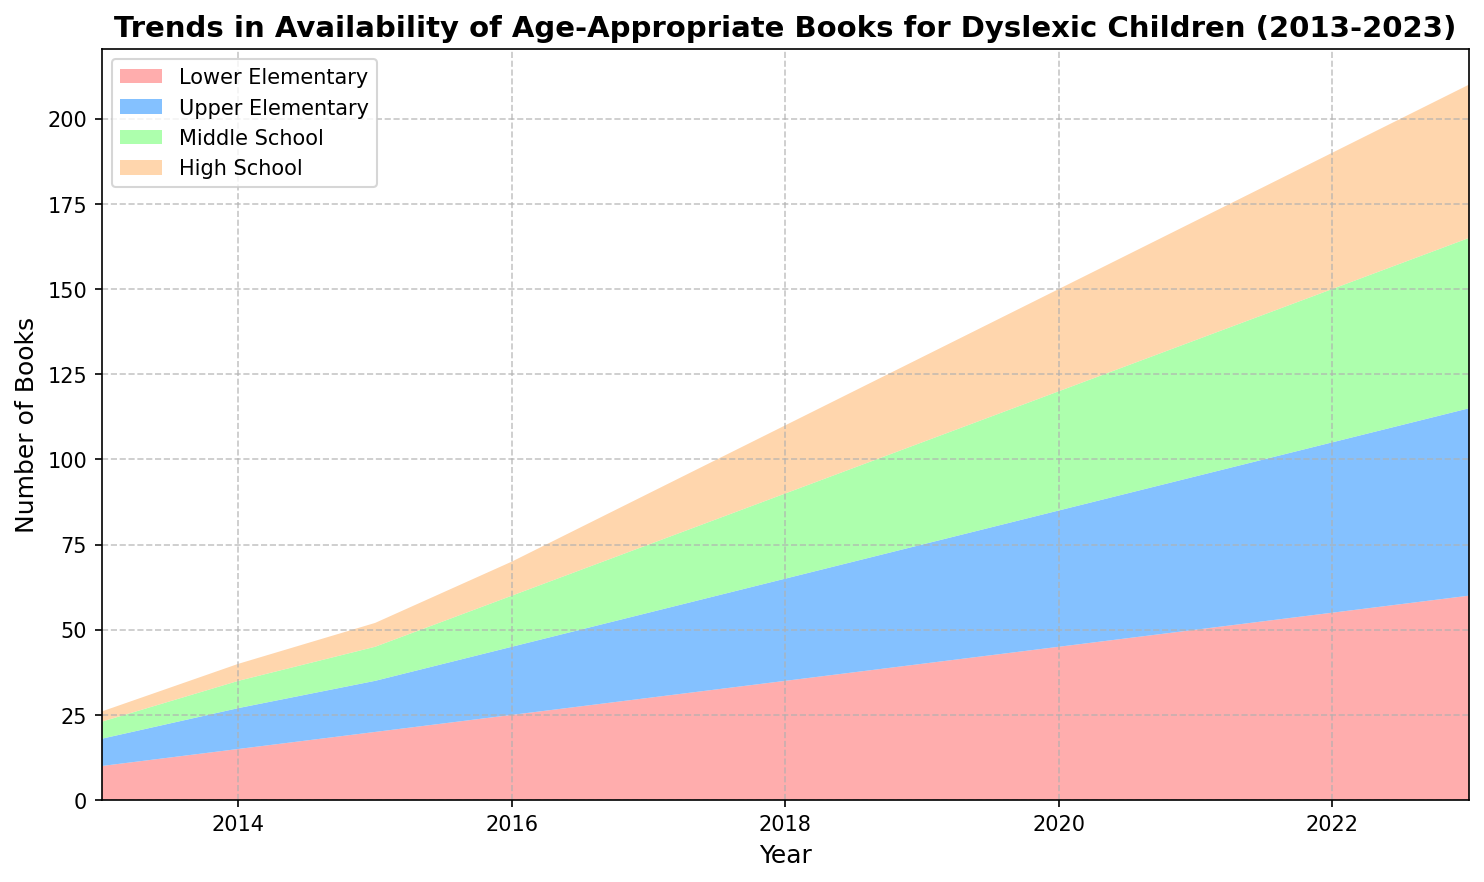What's the trend of availability of books for dyslexic children between 2013 and 2023? By observing the area chart from 2013 to 2023, there is a consistent upward trend across all the reading levels, indicating an increase in the availability of age-appropriate books for dyslexic children over the years.
Answer: Upward trend Which reading level had the highest number of books in 2023? In 2023, the area for 'Lower Elementary' extends the farthest up the y-axis, indicating that it had the highest number of books compared to other reading levels.
Answer: Lower Elementary What is the difference in the number of books available between High School and Middle School in 2023? In 2023, Middle School has 50 books while High School has 45 books. The difference is calculated as 50 - 45.
Answer: 5 How does the availability of Upper Elementary books in 2018 compare to those in 2016? From the chart, in 2018, the height of the 'Upper Elementary' segment is higher compared to 2016. Specifically, Upper Elementary had 30 books in 2018 and 20 books in 2016, showing an increase.
Answer: Higher in 2018 What's the change in the number of books for Lower Elementary from 2015 to 2020? Lower Elementary had 20 books in 2015 and increased to 45 books in 2020. The change is calculated as 45 - 20.
Answer: 25 Which two reading levels had the closest number of books in 2017? In 2017, both Middle School and High School had similar areas on the chart. Middle School had 20 books and High School had 15 books, which are the closest numbers compared to others.
Answer: Middle School and High School By how much did the availability of High School books increase from 2013 to 2017? High School had 3 books in 2013 and 15 books in 2017. The increase is calculated as 15 - 3.
Answer: 12 Considering Lower Elementary and Upper Elementary, which had a greater increase in book numbers from 2016 to 2021? From the chart, Lower Elementary increased from 25 books in 2016 to 50 books in 2021, while Upper Elementary increased from 20 books to 45 books in the same period. Lower Elementary's increase is 25, and Upper Elementary's increase is 25, so both had the same increase.
Answer: Both had the same increase 